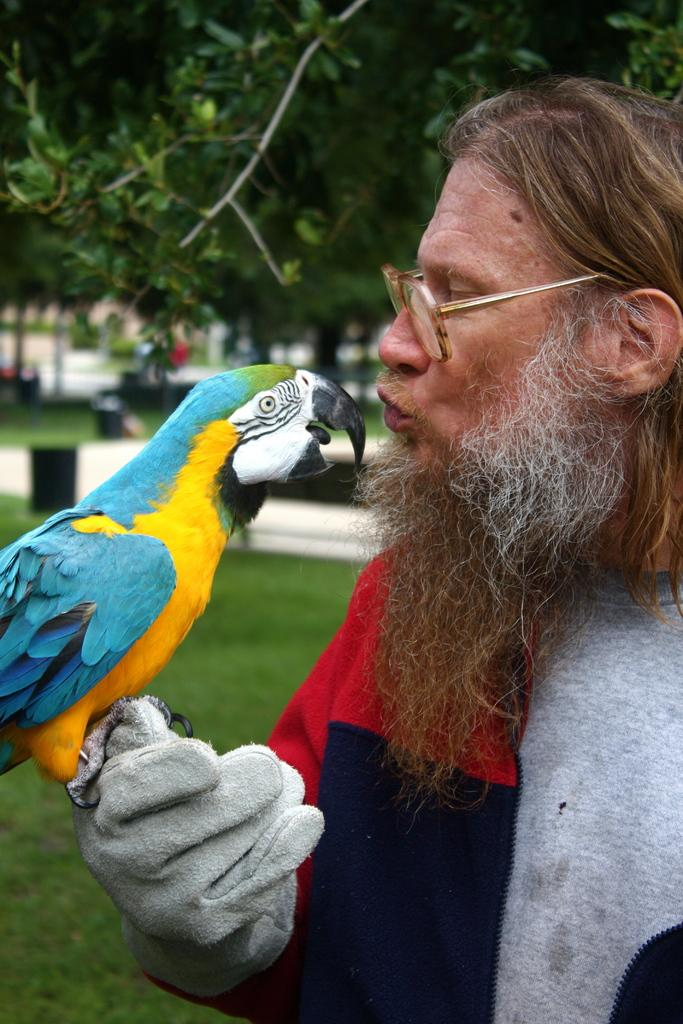What is the person in the image doing? The person is holding a colorful bird in the image. What can be seen on the person's face? The person is wearing spectacles in the image. Where is the person located in the image? The person is on the ground in the image. What type of vegetation is visible in the image? Trees are visible at the top of the image. What is the price of the soap in the image? There is no soap present in the image, so it is not possible to determine its price. 